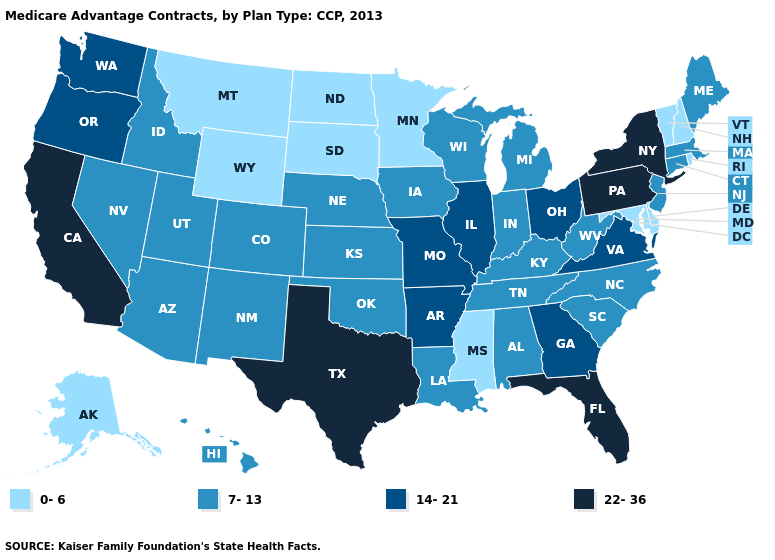What is the lowest value in states that border West Virginia?
Keep it brief. 0-6. What is the value of Nevada?
Short answer required. 7-13. Does the map have missing data?
Quick response, please. No. What is the value of Texas?
Short answer required. 22-36. Does Maryland have the highest value in the South?
Answer briefly. No. Does the map have missing data?
Quick response, please. No. Does Kansas have a higher value than Oregon?
Quick response, please. No. Does Colorado have the same value as Louisiana?
Concise answer only. Yes. What is the value of Hawaii?
Concise answer only. 7-13. Name the states that have a value in the range 7-13?
Short answer required. Alabama, Arizona, Colorado, Connecticut, Hawaii, Iowa, Idaho, Indiana, Kansas, Kentucky, Louisiana, Massachusetts, Maine, Michigan, North Carolina, Nebraska, New Jersey, New Mexico, Nevada, Oklahoma, South Carolina, Tennessee, Utah, Wisconsin, West Virginia. Does Alaska have a higher value than Kentucky?
Give a very brief answer. No. What is the highest value in the Northeast ?
Be succinct. 22-36. Does New York have the highest value in the USA?
Write a very short answer. Yes. What is the highest value in states that border Georgia?
Quick response, please. 22-36. Does Delaware have the same value as Maryland?
Write a very short answer. Yes. 